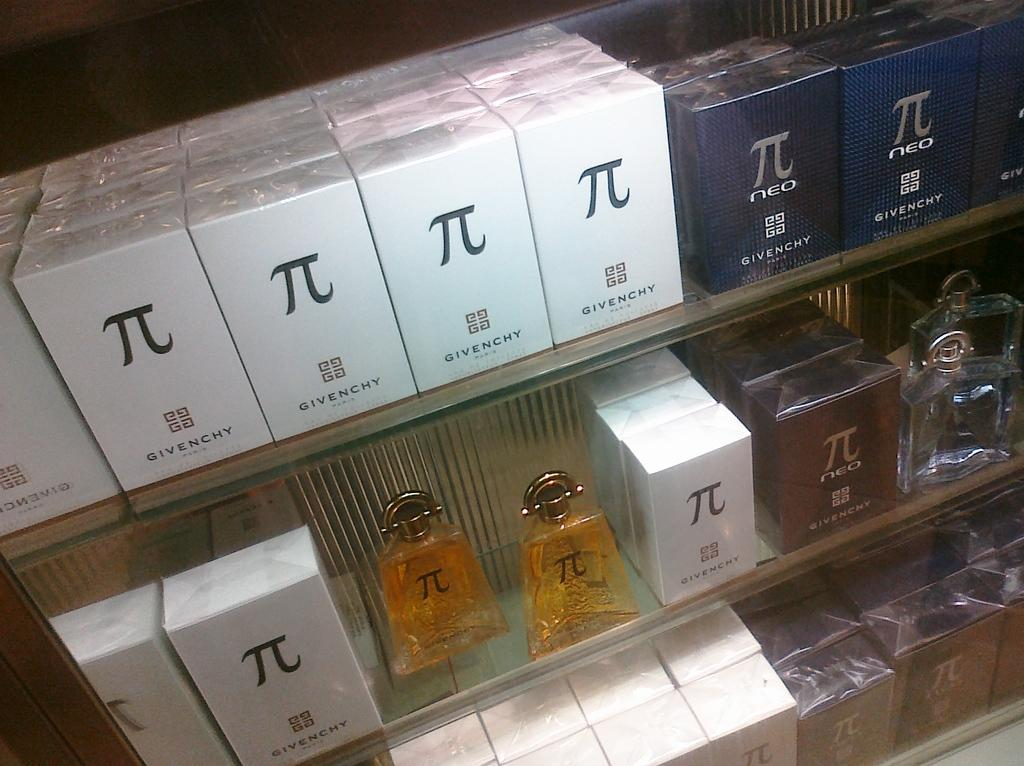<image>
Describe the image concisely. White, blue and brown boxes of PI branded cologne. 